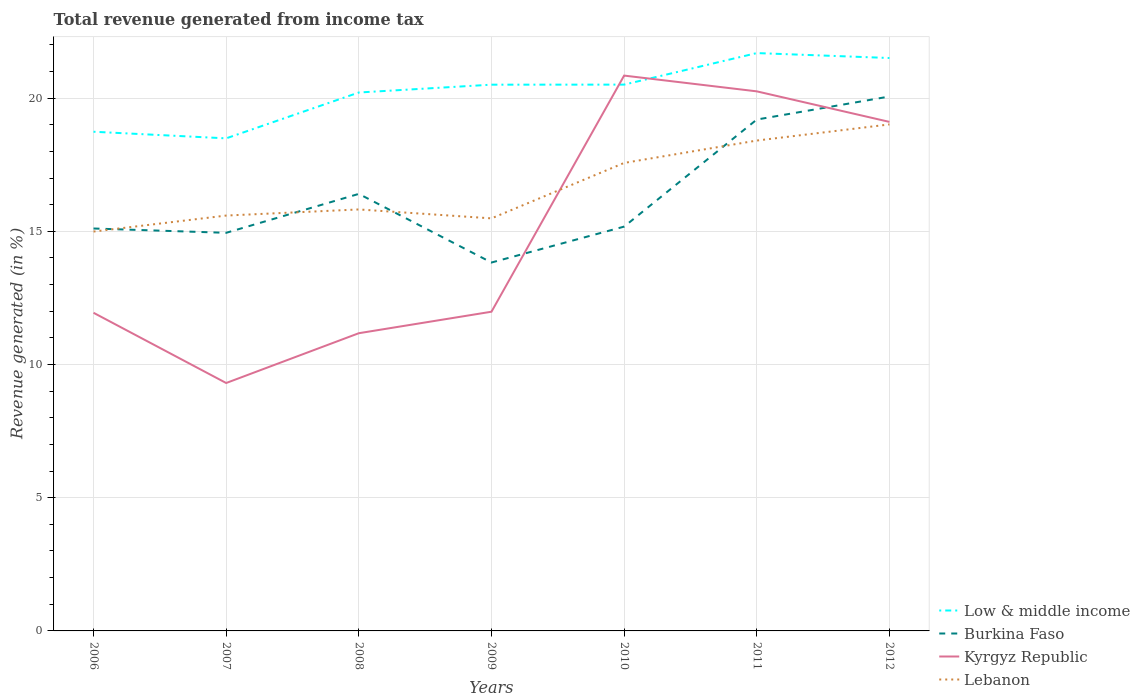Is the number of lines equal to the number of legend labels?
Your answer should be very brief. Yes. Across all years, what is the maximum total revenue generated in Low & middle income?
Your answer should be compact. 18.49. What is the total total revenue generated in Burkina Faso in the graph?
Ensure brevity in your answer.  1.28. What is the difference between the highest and the second highest total revenue generated in Low & middle income?
Make the answer very short. 3.2. What is the difference between the highest and the lowest total revenue generated in Lebanon?
Give a very brief answer. 3. Is the total revenue generated in Kyrgyz Republic strictly greater than the total revenue generated in Lebanon over the years?
Your answer should be compact. No. How many lines are there?
Give a very brief answer. 4. How many years are there in the graph?
Provide a short and direct response. 7. Does the graph contain grids?
Give a very brief answer. Yes. How many legend labels are there?
Give a very brief answer. 4. What is the title of the graph?
Offer a very short reply. Total revenue generated from income tax. What is the label or title of the Y-axis?
Give a very brief answer. Revenue generated (in %). What is the Revenue generated (in %) of Low & middle income in 2006?
Provide a short and direct response. 18.74. What is the Revenue generated (in %) in Burkina Faso in 2006?
Ensure brevity in your answer.  15.11. What is the Revenue generated (in %) in Kyrgyz Republic in 2006?
Provide a succinct answer. 11.94. What is the Revenue generated (in %) in Lebanon in 2006?
Ensure brevity in your answer.  14.99. What is the Revenue generated (in %) of Low & middle income in 2007?
Your response must be concise. 18.49. What is the Revenue generated (in %) in Burkina Faso in 2007?
Keep it short and to the point. 14.94. What is the Revenue generated (in %) in Kyrgyz Republic in 2007?
Your response must be concise. 9.31. What is the Revenue generated (in %) of Lebanon in 2007?
Offer a terse response. 15.59. What is the Revenue generated (in %) in Low & middle income in 2008?
Provide a short and direct response. 20.21. What is the Revenue generated (in %) of Burkina Faso in 2008?
Make the answer very short. 16.4. What is the Revenue generated (in %) of Kyrgyz Republic in 2008?
Offer a terse response. 11.17. What is the Revenue generated (in %) of Lebanon in 2008?
Offer a terse response. 15.82. What is the Revenue generated (in %) of Low & middle income in 2009?
Offer a very short reply. 20.5. What is the Revenue generated (in %) of Burkina Faso in 2009?
Your response must be concise. 13.83. What is the Revenue generated (in %) of Kyrgyz Republic in 2009?
Provide a short and direct response. 11.98. What is the Revenue generated (in %) of Lebanon in 2009?
Provide a short and direct response. 15.49. What is the Revenue generated (in %) of Low & middle income in 2010?
Make the answer very short. 20.51. What is the Revenue generated (in %) in Burkina Faso in 2010?
Ensure brevity in your answer.  15.18. What is the Revenue generated (in %) of Kyrgyz Republic in 2010?
Keep it short and to the point. 20.84. What is the Revenue generated (in %) of Lebanon in 2010?
Offer a terse response. 17.57. What is the Revenue generated (in %) in Low & middle income in 2011?
Ensure brevity in your answer.  21.69. What is the Revenue generated (in %) of Burkina Faso in 2011?
Your answer should be compact. 19.19. What is the Revenue generated (in %) in Kyrgyz Republic in 2011?
Ensure brevity in your answer.  20.25. What is the Revenue generated (in %) of Lebanon in 2011?
Ensure brevity in your answer.  18.41. What is the Revenue generated (in %) of Low & middle income in 2012?
Make the answer very short. 21.5. What is the Revenue generated (in %) in Burkina Faso in 2012?
Give a very brief answer. 20.06. What is the Revenue generated (in %) in Kyrgyz Republic in 2012?
Make the answer very short. 19.11. What is the Revenue generated (in %) of Lebanon in 2012?
Offer a terse response. 19.01. Across all years, what is the maximum Revenue generated (in %) of Low & middle income?
Offer a very short reply. 21.69. Across all years, what is the maximum Revenue generated (in %) of Burkina Faso?
Make the answer very short. 20.06. Across all years, what is the maximum Revenue generated (in %) in Kyrgyz Republic?
Offer a very short reply. 20.84. Across all years, what is the maximum Revenue generated (in %) in Lebanon?
Your answer should be very brief. 19.01. Across all years, what is the minimum Revenue generated (in %) in Low & middle income?
Your answer should be compact. 18.49. Across all years, what is the minimum Revenue generated (in %) in Burkina Faso?
Make the answer very short. 13.83. Across all years, what is the minimum Revenue generated (in %) in Kyrgyz Republic?
Your response must be concise. 9.31. Across all years, what is the minimum Revenue generated (in %) of Lebanon?
Make the answer very short. 14.99. What is the total Revenue generated (in %) in Low & middle income in the graph?
Your answer should be very brief. 141.64. What is the total Revenue generated (in %) in Burkina Faso in the graph?
Give a very brief answer. 114.71. What is the total Revenue generated (in %) of Kyrgyz Republic in the graph?
Ensure brevity in your answer.  104.61. What is the total Revenue generated (in %) of Lebanon in the graph?
Give a very brief answer. 116.87. What is the difference between the Revenue generated (in %) of Low & middle income in 2006 and that in 2007?
Your answer should be compact. 0.25. What is the difference between the Revenue generated (in %) of Burkina Faso in 2006 and that in 2007?
Make the answer very short. 0.16. What is the difference between the Revenue generated (in %) in Kyrgyz Republic in 2006 and that in 2007?
Your answer should be very brief. 2.64. What is the difference between the Revenue generated (in %) in Lebanon in 2006 and that in 2007?
Your response must be concise. -0.6. What is the difference between the Revenue generated (in %) in Low & middle income in 2006 and that in 2008?
Provide a short and direct response. -1.47. What is the difference between the Revenue generated (in %) of Burkina Faso in 2006 and that in 2008?
Give a very brief answer. -1.3. What is the difference between the Revenue generated (in %) in Kyrgyz Republic in 2006 and that in 2008?
Provide a succinct answer. 0.77. What is the difference between the Revenue generated (in %) of Lebanon in 2006 and that in 2008?
Give a very brief answer. -0.83. What is the difference between the Revenue generated (in %) in Low & middle income in 2006 and that in 2009?
Your answer should be very brief. -1.77. What is the difference between the Revenue generated (in %) of Burkina Faso in 2006 and that in 2009?
Give a very brief answer. 1.28. What is the difference between the Revenue generated (in %) of Kyrgyz Republic in 2006 and that in 2009?
Offer a very short reply. -0.04. What is the difference between the Revenue generated (in %) in Lebanon in 2006 and that in 2009?
Your answer should be compact. -0.49. What is the difference between the Revenue generated (in %) of Low & middle income in 2006 and that in 2010?
Make the answer very short. -1.77. What is the difference between the Revenue generated (in %) of Burkina Faso in 2006 and that in 2010?
Give a very brief answer. -0.07. What is the difference between the Revenue generated (in %) in Kyrgyz Republic in 2006 and that in 2010?
Keep it short and to the point. -8.9. What is the difference between the Revenue generated (in %) of Lebanon in 2006 and that in 2010?
Keep it short and to the point. -2.58. What is the difference between the Revenue generated (in %) of Low & middle income in 2006 and that in 2011?
Provide a short and direct response. -2.95. What is the difference between the Revenue generated (in %) of Burkina Faso in 2006 and that in 2011?
Your response must be concise. -4.09. What is the difference between the Revenue generated (in %) of Kyrgyz Republic in 2006 and that in 2011?
Provide a short and direct response. -8.31. What is the difference between the Revenue generated (in %) of Lebanon in 2006 and that in 2011?
Your answer should be compact. -3.42. What is the difference between the Revenue generated (in %) of Low & middle income in 2006 and that in 2012?
Your answer should be very brief. -2.77. What is the difference between the Revenue generated (in %) in Burkina Faso in 2006 and that in 2012?
Offer a very short reply. -4.95. What is the difference between the Revenue generated (in %) in Kyrgyz Republic in 2006 and that in 2012?
Your response must be concise. -7.17. What is the difference between the Revenue generated (in %) in Lebanon in 2006 and that in 2012?
Give a very brief answer. -4.02. What is the difference between the Revenue generated (in %) in Low & middle income in 2007 and that in 2008?
Keep it short and to the point. -1.72. What is the difference between the Revenue generated (in %) of Burkina Faso in 2007 and that in 2008?
Keep it short and to the point. -1.46. What is the difference between the Revenue generated (in %) in Kyrgyz Republic in 2007 and that in 2008?
Ensure brevity in your answer.  -1.87. What is the difference between the Revenue generated (in %) in Lebanon in 2007 and that in 2008?
Your answer should be very brief. -0.23. What is the difference between the Revenue generated (in %) of Low & middle income in 2007 and that in 2009?
Ensure brevity in your answer.  -2.02. What is the difference between the Revenue generated (in %) of Burkina Faso in 2007 and that in 2009?
Your answer should be very brief. 1.11. What is the difference between the Revenue generated (in %) in Kyrgyz Republic in 2007 and that in 2009?
Provide a short and direct response. -2.68. What is the difference between the Revenue generated (in %) in Lebanon in 2007 and that in 2009?
Your answer should be compact. 0.11. What is the difference between the Revenue generated (in %) of Low & middle income in 2007 and that in 2010?
Ensure brevity in your answer.  -2.02. What is the difference between the Revenue generated (in %) of Burkina Faso in 2007 and that in 2010?
Your response must be concise. -0.23. What is the difference between the Revenue generated (in %) in Kyrgyz Republic in 2007 and that in 2010?
Ensure brevity in your answer.  -11.54. What is the difference between the Revenue generated (in %) in Lebanon in 2007 and that in 2010?
Offer a terse response. -1.98. What is the difference between the Revenue generated (in %) in Low & middle income in 2007 and that in 2011?
Offer a very short reply. -3.2. What is the difference between the Revenue generated (in %) of Burkina Faso in 2007 and that in 2011?
Ensure brevity in your answer.  -4.25. What is the difference between the Revenue generated (in %) of Kyrgyz Republic in 2007 and that in 2011?
Keep it short and to the point. -10.95. What is the difference between the Revenue generated (in %) of Lebanon in 2007 and that in 2011?
Keep it short and to the point. -2.82. What is the difference between the Revenue generated (in %) of Low & middle income in 2007 and that in 2012?
Make the answer very short. -3.02. What is the difference between the Revenue generated (in %) of Burkina Faso in 2007 and that in 2012?
Offer a terse response. -5.12. What is the difference between the Revenue generated (in %) in Kyrgyz Republic in 2007 and that in 2012?
Ensure brevity in your answer.  -9.8. What is the difference between the Revenue generated (in %) in Lebanon in 2007 and that in 2012?
Provide a short and direct response. -3.42. What is the difference between the Revenue generated (in %) of Low & middle income in 2008 and that in 2009?
Your answer should be very brief. -0.29. What is the difference between the Revenue generated (in %) of Burkina Faso in 2008 and that in 2009?
Provide a short and direct response. 2.58. What is the difference between the Revenue generated (in %) in Kyrgyz Republic in 2008 and that in 2009?
Provide a short and direct response. -0.81. What is the difference between the Revenue generated (in %) in Lebanon in 2008 and that in 2009?
Offer a very short reply. 0.34. What is the difference between the Revenue generated (in %) of Low & middle income in 2008 and that in 2010?
Ensure brevity in your answer.  -0.3. What is the difference between the Revenue generated (in %) in Burkina Faso in 2008 and that in 2010?
Provide a short and direct response. 1.23. What is the difference between the Revenue generated (in %) in Kyrgyz Republic in 2008 and that in 2010?
Your response must be concise. -9.67. What is the difference between the Revenue generated (in %) in Lebanon in 2008 and that in 2010?
Provide a short and direct response. -1.75. What is the difference between the Revenue generated (in %) of Low & middle income in 2008 and that in 2011?
Provide a succinct answer. -1.48. What is the difference between the Revenue generated (in %) of Burkina Faso in 2008 and that in 2011?
Your answer should be compact. -2.79. What is the difference between the Revenue generated (in %) in Kyrgyz Republic in 2008 and that in 2011?
Give a very brief answer. -9.08. What is the difference between the Revenue generated (in %) of Lebanon in 2008 and that in 2011?
Give a very brief answer. -2.59. What is the difference between the Revenue generated (in %) of Low & middle income in 2008 and that in 2012?
Make the answer very short. -1.29. What is the difference between the Revenue generated (in %) in Burkina Faso in 2008 and that in 2012?
Offer a terse response. -3.66. What is the difference between the Revenue generated (in %) in Kyrgyz Republic in 2008 and that in 2012?
Provide a succinct answer. -7.93. What is the difference between the Revenue generated (in %) of Lebanon in 2008 and that in 2012?
Keep it short and to the point. -3.19. What is the difference between the Revenue generated (in %) in Low & middle income in 2009 and that in 2010?
Offer a very short reply. -0. What is the difference between the Revenue generated (in %) of Burkina Faso in 2009 and that in 2010?
Keep it short and to the point. -1.35. What is the difference between the Revenue generated (in %) in Kyrgyz Republic in 2009 and that in 2010?
Provide a succinct answer. -8.86. What is the difference between the Revenue generated (in %) in Lebanon in 2009 and that in 2010?
Keep it short and to the point. -2.08. What is the difference between the Revenue generated (in %) in Low & middle income in 2009 and that in 2011?
Offer a terse response. -1.19. What is the difference between the Revenue generated (in %) in Burkina Faso in 2009 and that in 2011?
Offer a terse response. -5.37. What is the difference between the Revenue generated (in %) in Kyrgyz Republic in 2009 and that in 2011?
Offer a terse response. -8.27. What is the difference between the Revenue generated (in %) in Lebanon in 2009 and that in 2011?
Offer a terse response. -2.92. What is the difference between the Revenue generated (in %) of Low & middle income in 2009 and that in 2012?
Keep it short and to the point. -1. What is the difference between the Revenue generated (in %) in Burkina Faso in 2009 and that in 2012?
Make the answer very short. -6.23. What is the difference between the Revenue generated (in %) in Kyrgyz Republic in 2009 and that in 2012?
Make the answer very short. -7.13. What is the difference between the Revenue generated (in %) of Lebanon in 2009 and that in 2012?
Offer a terse response. -3.53. What is the difference between the Revenue generated (in %) of Low & middle income in 2010 and that in 2011?
Provide a succinct answer. -1.18. What is the difference between the Revenue generated (in %) of Burkina Faso in 2010 and that in 2011?
Keep it short and to the point. -4.02. What is the difference between the Revenue generated (in %) in Kyrgyz Republic in 2010 and that in 2011?
Your answer should be compact. 0.59. What is the difference between the Revenue generated (in %) of Lebanon in 2010 and that in 2011?
Your answer should be compact. -0.84. What is the difference between the Revenue generated (in %) of Low & middle income in 2010 and that in 2012?
Provide a succinct answer. -1. What is the difference between the Revenue generated (in %) in Burkina Faso in 2010 and that in 2012?
Offer a terse response. -4.88. What is the difference between the Revenue generated (in %) in Kyrgyz Republic in 2010 and that in 2012?
Ensure brevity in your answer.  1.74. What is the difference between the Revenue generated (in %) of Lebanon in 2010 and that in 2012?
Make the answer very short. -1.45. What is the difference between the Revenue generated (in %) of Low & middle income in 2011 and that in 2012?
Your answer should be very brief. 0.19. What is the difference between the Revenue generated (in %) in Burkina Faso in 2011 and that in 2012?
Provide a short and direct response. -0.87. What is the difference between the Revenue generated (in %) of Kyrgyz Republic in 2011 and that in 2012?
Your response must be concise. 1.15. What is the difference between the Revenue generated (in %) of Lebanon in 2011 and that in 2012?
Your answer should be very brief. -0.61. What is the difference between the Revenue generated (in %) in Low & middle income in 2006 and the Revenue generated (in %) in Burkina Faso in 2007?
Keep it short and to the point. 3.79. What is the difference between the Revenue generated (in %) of Low & middle income in 2006 and the Revenue generated (in %) of Kyrgyz Republic in 2007?
Offer a very short reply. 9.43. What is the difference between the Revenue generated (in %) in Low & middle income in 2006 and the Revenue generated (in %) in Lebanon in 2007?
Keep it short and to the point. 3.15. What is the difference between the Revenue generated (in %) in Burkina Faso in 2006 and the Revenue generated (in %) in Kyrgyz Republic in 2007?
Your answer should be very brief. 5.8. What is the difference between the Revenue generated (in %) in Burkina Faso in 2006 and the Revenue generated (in %) in Lebanon in 2007?
Your answer should be compact. -0.49. What is the difference between the Revenue generated (in %) of Kyrgyz Republic in 2006 and the Revenue generated (in %) of Lebanon in 2007?
Offer a terse response. -3.65. What is the difference between the Revenue generated (in %) in Low & middle income in 2006 and the Revenue generated (in %) in Burkina Faso in 2008?
Ensure brevity in your answer.  2.33. What is the difference between the Revenue generated (in %) of Low & middle income in 2006 and the Revenue generated (in %) of Kyrgyz Republic in 2008?
Ensure brevity in your answer.  7.56. What is the difference between the Revenue generated (in %) of Low & middle income in 2006 and the Revenue generated (in %) of Lebanon in 2008?
Ensure brevity in your answer.  2.92. What is the difference between the Revenue generated (in %) in Burkina Faso in 2006 and the Revenue generated (in %) in Kyrgyz Republic in 2008?
Make the answer very short. 3.93. What is the difference between the Revenue generated (in %) in Burkina Faso in 2006 and the Revenue generated (in %) in Lebanon in 2008?
Offer a terse response. -0.72. What is the difference between the Revenue generated (in %) in Kyrgyz Republic in 2006 and the Revenue generated (in %) in Lebanon in 2008?
Give a very brief answer. -3.88. What is the difference between the Revenue generated (in %) in Low & middle income in 2006 and the Revenue generated (in %) in Burkina Faso in 2009?
Give a very brief answer. 4.91. What is the difference between the Revenue generated (in %) in Low & middle income in 2006 and the Revenue generated (in %) in Kyrgyz Republic in 2009?
Keep it short and to the point. 6.76. What is the difference between the Revenue generated (in %) of Low & middle income in 2006 and the Revenue generated (in %) of Lebanon in 2009?
Ensure brevity in your answer.  3.25. What is the difference between the Revenue generated (in %) of Burkina Faso in 2006 and the Revenue generated (in %) of Kyrgyz Republic in 2009?
Give a very brief answer. 3.12. What is the difference between the Revenue generated (in %) in Burkina Faso in 2006 and the Revenue generated (in %) in Lebanon in 2009?
Provide a succinct answer. -0.38. What is the difference between the Revenue generated (in %) in Kyrgyz Republic in 2006 and the Revenue generated (in %) in Lebanon in 2009?
Provide a short and direct response. -3.54. What is the difference between the Revenue generated (in %) of Low & middle income in 2006 and the Revenue generated (in %) of Burkina Faso in 2010?
Your answer should be compact. 3.56. What is the difference between the Revenue generated (in %) of Low & middle income in 2006 and the Revenue generated (in %) of Kyrgyz Republic in 2010?
Give a very brief answer. -2.11. What is the difference between the Revenue generated (in %) of Low & middle income in 2006 and the Revenue generated (in %) of Lebanon in 2010?
Your response must be concise. 1.17. What is the difference between the Revenue generated (in %) in Burkina Faso in 2006 and the Revenue generated (in %) in Kyrgyz Republic in 2010?
Provide a succinct answer. -5.74. What is the difference between the Revenue generated (in %) in Burkina Faso in 2006 and the Revenue generated (in %) in Lebanon in 2010?
Your answer should be very brief. -2.46. What is the difference between the Revenue generated (in %) in Kyrgyz Republic in 2006 and the Revenue generated (in %) in Lebanon in 2010?
Your answer should be very brief. -5.62. What is the difference between the Revenue generated (in %) of Low & middle income in 2006 and the Revenue generated (in %) of Burkina Faso in 2011?
Offer a terse response. -0.46. What is the difference between the Revenue generated (in %) in Low & middle income in 2006 and the Revenue generated (in %) in Kyrgyz Republic in 2011?
Offer a terse response. -1.52. What is the difference between the Revenue generated (in %) of Low & middle income in 2006 and the Revenue generated (in %) of Lebanon in 2011?
Provide a short and direct response. 0.33. What is the difference between the Revenue generated (in %) in Burkina Faso in 2006 and the Revenue generated (in %) in Kyrgyz Republic in 2011?
Give a very brief answer. -5.15. What is the difference between the Revenue generated (in %) of Burkina Faso in 2006 and the Revenue generated (in %) of Lebanon in 2011?
Provide a succinct answer. -3.3. What is the difference between the Revenue generated (in %) of Kyrgyz Republic in 2006 and the Revenue generated (in %) of Lebanon in 2011?
Offer a very short reply. -6.46. What is the difference between the Revenue generated (in %) of Low & middle income in 2006 and the Revenue generated (in %) of Burkina Faso in 2012?
Your answer should be compact. -1.32. What is the difference between the Revenue generated (in %) in Low & middle income in 2006 and the Revenue generated (in %) in Kyrgyz Republic in 2012?
Give a very brief answer. -0.37. What is the difference between the Revenue generated (in %) of Low & middle income in 2006 and the Revenue generated (in %) of Lebanon in 2012?
Provide a short and direct response. -0.28. What is the difference between the Revenue generated (in %) in Burkina Faso in 2006 and the Revenue generated (in %) in Kyrgyz Republic in 2012?
Your answer should be compact. -4. What is the difference between the Revenue generated (in %) of Burkina Faso in 2006 and the Revenue generated (in %) of Lebanon in 2012?
Give a very brief answer. -3.91. What is the difference between the Revenue generated (in %) of Kyrgyz Republic in 2006 and the Revenue generated (in %) of Lebanon in 2012?
Offer a very short reply. -7.07. What is the difference between the Revenue generated (in %) in Low & middle income in 2007 and the Revenue generated (in %) in Burkina Faso in 2008?
Keep it short and to the point. 2.08. What is the difference between the Revenue generated (in %) of Low & middle income in 2007 and the Revenue generated (in %) of Kyrgyz Republic in 2008?
Your answer should be compact. 7.31. What is the difference between the Revenue generated (in %) in Low & middle income in 2007 and the Revenue generated (in %) in Lebanon in 2008?
Give a very brief answer. 2.67. What is the difference between the Revenue generated (in %) in Burkina Faso in 2007 and the Revenue generated (in %) in Kyrgyz Republic in 2008?
Offer a terse response. 3.77. What is the difference between the Revenue generated (in %) of Burkina Faso in 2007 and the Revenue generated (in %) of Lebanon in 2008?
Make the answer very short. -0.88. What is the difference between the Revenue generated (in %) of Kyrgyz Republic in 2007 and the Revenue generated (in %) of Lebanon in 2008?
Your response must be concise. -6.51. What is the difference between the Revenue generated (in %) of Low & middle income in 2007 and the Revenue generated (in %) of Burkina Faso in 2009?
Make the answer very short. 4.66. What is the difference between the Revenue generated (in %) of Low & middle income in 2007 and the Revenue generated (in %) of Kyrgyz Republic in 2009?
Offer a terse response. 6.51. What is the difference between the Revenue generated (in %) in Low & middle income in 2007 and the Revenue generated (in %) in Lebanon in 2009?
Offer a terse response. 3. What is the difference between the Revenue generated (in %) of Burkina Faso in 2007 and the Revenue generated (in %) of Kyrgyz Republic in 2009?
Your answer should be compact. 2.96. What is the difference between the Revenue generated (in %) in Burkina Faso in 2007 and the Revenue generated (in %) in Lebanon in 2009?
Ensure brevity in your answer.  -0.54. What is the difference between the Revenue generated (in %) of Kyrgyz Republic in 2007 and the Revenue generated (in %) of Lebanon in 2009?
Make the answer very short. -6.18. What is the difference between the Revenue generated (in %) in Low & middle income in 2007 and the Revenue generated (in %) in Burkina Faso in 2010?
Make the answer very short. 3.31. What is the difference between the Revenue generated (in %) of Low & middle income in 2007 and the Revenue generated (in %) of Kyrgyz Republic in 2010?
Offer a very short reply. -2.36. What is the difference between the Revenue generated (in %) of Low & middle income in 2007 and the Revenue generated (in %) of Lebanon in 2010?
Offer a terse response. 0.92. What is the difference between the Revenue generated (in %) of Burkina Faso in 2007 and the Revenue generated (in %) of Kyrgyz Republic in 2010?
Your answer should be very brief. -5.9. What is the difference between the Revenue generated (in %) of Burkina Faso in 2007 and the Revenue generated (in %) of Lebanon in 2010?
Make the answer very short. -2.62. What is the difference between the Revenue generated (in %) of Kyrgyz Republic in 2007 and the Revenue generated (in %) of Lebanon in 2010?
Provide a short and direct response. -8.26. What is the difference between the Revenue generated (in %) of Low & middle income in 2007 and the Revenue generated (in %) of Burkina Faso in 2011?
Offer a terse response. -0.71. What is the difference between the Revenue generated (in %) of Low & middle income in 2007 and the Revenue generated (in %) of Kyrgyz Republic in 2011?
Provide a short and direct response. -1.76. What is the difference between the Revenue generated (in %) of Low & middle income in 2007 and the Revenue generated (in %) of Lebanon in 2011?
Make the answer very short. 0.08. What is the difference between the Revenue generated (in %) of Burkina Faso in 2007 and the Revenue generated (in %) of Kyrgyz Republic in 2011?
Offer a very short reply. -5.31. What is the difference between the Revenue generated (in %) of Burkina Faso in 2007 and the Revenue generated (in %) of Lebanon in 2011?
Provide a succinct answer. -3.46. What is the difference between the Revenue generated (in %) of Kyrgyz Republic in 2007 and the Revenue generated (in %) of Lebanon in 2011?
Your answer should be very brief. -9.1. What is the difference between the Revenue generated (in %) in Low & middle income in 2007 and the Revenue generated (in %) in Burkina Faso in 2012?
Your response must be concise. -1.57. What is the difference between the Revenue generated (in %) in Low & middle income in 2007 and the Revenue generated (in %) in Kyrgyz Republic in 2012?
Offer a terse response. -0.62. What is the difference between the Revenue generated (in %) in Low & middle income in 2007 and the Revenue generated (in %) in Lebanon in 2012?
Offer a very short reply. -0.52. What is the difference between the Revenue generated (in %) of Burkina Faso in 2007 and the Revenue generated (in %) of Kyrgyz Republic in 2012?
Keep it short and to the point. -4.16. What is the difference between the Revenue generated (in %) of Burkina Faso in 2007 and the Revenue generated (in %) of Lebanon in 2012?
Your answer should be compact. -4.07. What is the difference between the Revenue generated (in %) in Kyrgyz Republic in 2007 and the Revenue generated (in %) in Lebanon in 2012?
Give a very brief answer. -9.71. What is the difference between the Revenue generated (in %) in Low & middle income in 2008 and the Revenue generated (in %) in Burkina Faso in 2009?
Provide a succinct answer. 6.38. What is the difference between the Revenue generated (in %) in Low & middle income in 2008 and the Revenue generated (in %) in Kyrgyz Republic in 2009?
Your answer should be very brief. 8.23. What is the difference between the Revenue generated (in %) in Low & middle income in 2008 and the Revenue generated (in %) in Lebanon in 2009?
Make the answer very short. 4.72. What is the difference between the Revenue generated (in %) in Burkina Faso in 2008 and the Revenue generated (in %) in Kyrgyz Republic in 2009?
Ensure brevity in your answer.  4.42. What is the difference between the Revenue generated (in %) of Burkina Faso in 2008 and the Revenue generated (in %) of Lebanon in 2009?
Ensure brevity in your answer.  0.92. What is the difference between the Revenue generated (in %) in Kyrgyz Republic in 2008 and the Revenue generated (in %) in Lebanon in 2009?
Give a very brief answer. -4.31. What is the difference between the Revenue generated (in %) of Low & middle income in 2008 and the Revenue generated (in %) of Burkina Faso in 2010?
Offer a terse response. 5.03. What is the difference between the Revenue generated (in %) of Low & middle income in 2008 and the Revenue generated (in %) of Kyrgyz Republic in 2010?
Offer a very short reply. -0.64. What is the difference between the Revenue generated (in %) of Low & middle income in 2008 and the Revenue generated (in %) of Lebanon in 2010?
Keep it short and to the point. 2.64. What is the difference between the Revenue generated (in %) in Burkina Faso in 2008 and the Revenue generated (in %) in Kyrgyz Republic in 2010?
Your answer should be very brief. -4.44. What is the difference between the Revenue generated (in %) of Burkina Faso in 2008 and the Revenue generated (in %) of Lebanon in 2010?
Provide a succinct answer. -1.16. What is the difference between the Revenue generated (in %) in Kyrgyz Republic in 2008 and the Revenue generated (in %) in Lebanon in 2010?
Ensure brevity in your answer.  -6.39. What is the difference between the Revenue generated (in %) in Low & middle income in 2008 and the Revenue generated (in %) in Burkina Faso in 2011?
Give a very brief answer. 1.01. What is the difference between the Revenue generated (in %) in Low & middle income in 2008 and the Revenue generated (in %) in Kyrgyz Republic in 2011?
Keep it short and to the point. -0.04. What is the difference between the Revenue generated (in %) of Low & middle income in 2008 and the Revenue generated (in %) of Lebanon in 2011?
Make the answer very short. 1.8. What is the difference between the Revenue generated (in %) in Burkina Faso in 2008 and the Revenue generated (in %) in Kyrgyz Republic in 2011?
Your answer should be very brief. -3.85. What is the difference between the Revenue generated (in %) of Burkina Faso in 2008 and the Revenue generated (in %) of Lebanon in 2011?
Provide a short and direct response. -2. What is the difference between the Revenue generated (in %) of Kyrgyz Republic in 2008 and the Revenue generated (in %) of Lebanon in 2011?
Ensure brevity in your answer.  -7.23. What is the difference between the Revenue generated (in %) of Low & middle income in 2008 and the Revenue generated (in %) of Burkina Faso in 2012?
Offer a very short reply. 0.15. What is the difference between the Revenue generated (in %) of Low & middle income in 2008 and the Revenue generated (in %) of Kyrgyz Republic in 2012?
Your response must be concise. 1.1. What is the difference between the Revenue generated (in %) of Low & middle income in 2008 and the Revenue generated (in %) of Lebanon in 2012?
Your response must be concise. 1.2. What is the difference between the Revenue generated (in %) of Burkina Faso in 2008 and the Revenue generated (in %) of Kyrgyz Republic in 2012?
Provide a short and direct response. -2.7. What is the difference between the Revenue generated (in %) of Burkina Faso in 2008 and the Revenue generated (in %) of Lebanon in 2012?
Provide a short and direct response. -2.61. What is the difference between the Revenue generated (in %) of Kyrgyz Republic in 2008 and the Revenue generated (in %) of Lebanon in 2012?
Your answer should be very brief. -7.84. What is the difference between the Revenue generated (in %) of Low & middle income in 2009 and the Revenue generated (in %) of Burkina Faso in 2010?
Provide a short and direct response. 5.33. What is the difference between the Revenue generated (in %) of Low & middle income in 2009 and the Revenue generated (in %) of Kyrgyz Republic in 2010?
Ensure brevity in your answer.  -0.34. What is the difference between the Revenue generated (in %) in Low & middle income in 2009 and the Revenue generated (in %) in Lebanon in 2010?
Provide a succinct answer. 2.94. What is the difference between the Revenue generated (in %) in Burkina Faso in 2009 and the Revenue generated (in %) in Kyrgyz Republic in 2010?
Provide a succinct answer. -7.02. What is the difference between the Revenue generated (in %) of Burkina Faso in 2009 and the Revenue generated (in %) of Lebanon in 2010?
Give a very brief answer. -3.74. What is the difference between the Revenue generated (in %) of Kyrgyz Republic in 2009 and the Revenue generated (in %) of Lebanon in 2010?
Your answer should be very brief. -5.59. What is the difference between the Revenue generated (in %) in Low & middle income in 2009 and the Revenue generated (in %) in Burkina Faso in 2011?
Give a very brief answer. 1.31. What is the difference between the Revenue generated (in %) in Low & middle income in 2009 and the Revenue generated (in %) in Kyrgyz Republic in 2011?
Provide a succinct answer. 0.25. What is the difference between the Revenue generated (in %) in Low & middle income in 2009 and the Revenue generated (in %) in Lebanon in 2011?
Your response must be concise. 2.1. What is the difference between the Revenue generated (in %) in Burkina Faso in 2009 and the Revenue generated (in %) in Kyrgyz Republic in 2011?
Make the answer very short. -6.42. What is the difference between the Revenue generated (in %) in Burkina Faso in 2009 and the Revenue generated (in %) in Lebanon in 2011?
Provide a short and direct response. -4.58. What is the difference between the Revenue generated (in %) of Kyrgyz Republic in 2009 and the Revenue generated (in %) of Lebanon in 2011?
Provide a short and direct response. -6.42. What is the difference between the Revenue generated (in %) of Low & middle income in 2009 and the Revenue generated (in %) of Burkina Faso in 2012?
Ensure brevity in your answer.  0.44. What is the difference between the Revenue generated (in %) of Low & middle income in 2009 and the Revenue generated (in %) of Kyrgyz Republic in 2012?
Your answer should be compact. 1.4. What is the difference between the Revenue generated (in %) in Low & middle income in 2009 and the Revenue generated (in %) in Lebanon in 2012?
Provide a short and direct response. 1.49. What is the difference between the Revenue generated (in %) in Burkina Faso in 2009 and the Revenue generated (in %) in Kyrgyz Republic in 2012?
Keep it short and to the point. -5.28. What is the difference between the Revenue generated (in %) in Burkina Faso in 2009 and the Revenue generated (in %) in Lebanon in 2012?
Ensure brevity in your answer.  -5.18. What is the difference between the Revenue generated (in %) in Kyrgyz Republic in 2009 and the Revenue generated (in %) in Lebanon in 2012?
Your answer should be compact. -7.03. What is the difference between the Revenue generated (in %) in Low & middle income in 2010 and the Revenue generated (in %) in Burkina Faso in 2011?
Your answer should be very brief. 1.31. What is the difference between the Revenue generated (in %) in Low & middle income in 2010 and the Revenue generated (in %) in Kyrgyz Republic in 2011?
Your answer should be compact. 0.25. What is the difference between the Revenue generated (in %) of Low & middle income in 2010 and the Revenue generated (in %) of Lebanon in 2011?
Your answer should be very brief. 2.1. What is the difference between the Revenue generated (in %) in Burkina Faso in 2010 and the Revenue generated (in %) in Kyrgyz Republic in 2011?
Ensure brevity in your answer.  -5.08. What is the difference between the Revenue generated (in %) in Burkina Faso in 2010 and the Revenue generated (in %) in Lebanon in 2011?
Provide a succinct answer. -3.23. What is the difference between the Revenue generated (in %) of Kyrgyz Republic in 2010 and the Revenue generated (in %) of Lebanon in 2011?
Make the answer very short. 2.44. What is the difference between the Revenue generated (in %) of Low & middle income in 2010 and the Revenue generated (in %) of Burkina Faso in 2012?
Offer a very short reply. 0.45. What is the difference between the Revenue generated (in %) of Low & middle income in 2010 and the Revenue generated (in %) of Kyrgyz Republic in 2012?
Offer a terse response. 1.4. What is the difference between the Revenue generated (in %) of Low & middle income in 2010 and the Revenue generated (in %) of Lebanon in 2012?
Your response must be concise. 1.49. What is the difference between the Revenue generated (in %) of Burkina Faso in 2010 and the Revenue generated (in %) of Kyrgyz Republic in 2012?
Your response must be concise. -3.93. What is the difference between the Revenue generated (in %) in Burkina Faso in 2010 and the Revenue generated (in %) in Lebanon in 2012?
Offer a terse response. -3.84. What is the difference between the Revenue generated (in %) in Kyrgyz Republic in 2010 and the Revenue generated (in %) in Lebanon in 2012?
Offer a very short reply. 1.83. What is the difference between the Revenue generated (in %) of Low & middle income in 2011 and the Revenue generated (in %) of Burkina Faso in 2012?
Keep it short and to the point. 1.63. What is the difference between the Revenue generated (in %) of Low & middle income in 2011 and the Revenue generated (in %) of Kyrgyz Republic in 2012?
Your response must be concise. 2.58. What is the difference between the Revenue generated (in %) in Low & middle income in 2011 and the Revenue generated (in %) in Lebanon in 2012?
Provide a short and direct response. 2.68. What is the difference between the Revenue generated (in %) in Burkina Faso in 2011 and the Revenue generated (in %) in Kyrgyz Republic in 2012?
Your answer should be very brief. 0.09. What is the difference between the Revenue generated (in %) in Burkina Faso in 2011 and the Revenue generated (in %) in Lebanon in 2012?
Your answer should be compact. 0.18. What is the difference between the Revenue generated (in %) of Kyrgyz Republic in 2011 and the Revenue generated (in %) of Lebanon in 2012?
Ensure brevity in your answer.  1.24. What is the average Revenue generated (in %) in Low & middle income per year?
Ensure brevity in your answer.  20.23. What is the average Revenue generated (in %) of Burkina Faso per year?
Provide a short and direct response. 16.39. What is the average Revenue generated (in %) in Kyrgyz Republic per year?
Offer a terse response. 14.94. What is the average Revenue generated (in %) of Lebanon per year?
Provide a succinct answer. 16.7. In the year 2006, what is the difference between the Revenue generated (in %) in Low & middle income and Revenue generated (in %) in Burkina Faso?
Provide a short and direct response. 3.63. In the year 2006, what is the difference between the Revenue generated (in %) of Low & middle income and Revenue generated (in %) of Kyrgyz Republic?
Give a very brief answer. 6.8. In the year 2006, what is the difference between the Revenue generated (in %) in Low & middle income and Revenue generated (in %) in Lebanon?
Offer a terse response. 3.75. In the year 2006, what is the difference between the Revenue generated (in %) in Burkina Faso and Revenue generated (in %) in Kyrgyz Republic?
Offer a terse response. 3.16. In the year 2006, what is the difference between the Revenue generated (in %) in Burkina Faso and Revenue generated (in %) in Lebanon?
Your response must be concise. 0.11. In the year 2006, what is the difference between the Revenue generated (in %) of Kyrgyz Republic and Revenue generated (in %) of Lebanon?
Keep it short and to the point. -3.05. In the year 2007, what is the difference between the Revenue generated (in %) of Low & middle income and Revenue generated (in %) of Burkina Faso?
Your answer should be very brief. 3.55. In the year 2007, what is the difference between the Revenue generated (in %) of Low & middle income and Revenue generated (in %) of Kyrgyz Republic?
Provide a short and direct response. 9.18. In the year 2007, what is the difference between the Revenue generated (in %) in Low & middle income and Revenue generated (in %) in Lebanon?
Offer a very short reply. 2.9. In the year 2007, what is the difference between the Revenue generated (in %) of Burkina Faso and Revenue generated (in %) of Kyrgyz Republic?
Your answer should be compact. 5.64. In the year 2007, what is the difference between the Revenue generated (in %) of Burkina Faso and Revenue generated (in %) of Lebanon?
Your response must be concise. -0.65. In the year 2007, what is the difference between the Revenue generated (in %) of Kyrgyz Republic and Revenue generated (in %) of Lebanon?
Your answer should be very brief. -6.29. In the year 2008, what is the difference between the Revenue generated (in %) of Low & middle income and Revenue generated (in %) of Burkina Faso?
Provide a short and direct response. 3.81. In the year 2008, what is the difference between the Revenue generated (in %) of Low & middle income and Revenue generated (in %) of Kyrgyz Republic?
Make the answer very short. 9.04. In the year 2008, what is the difference between the Revenue generated (in %) of Low & middle income and Revenue generated (in %) of Lebanon?
Keep it short and to the point. 4.39. In the year 2008, what is the difference between the Revenue generated (in %) in Burkina Faso and Revenue generated (in %) in Kyrgyz Republic?
Offer a terse response. 5.23. In the year 2008, what is the difference between the Revenue generated (in %) of Burkina Faso and Revenue generated (in %) of Lebanon?
Ensure brevity in your answer.  0.58. In the year 2008, what is the difference between the Revenue generated (in %) of Kyrgyz Republic and Revenue generated (in %) of Lebanon?
Your answer should be compact. -4.65. In the year 2009, what is the difference between the Revenue generated (in %) in Low & middle income and Revenue generated (in %) in Burkina Faso?
Your answer should be compact. 6.68. In the year 2009, what is the difference between the Revenue generated (in %) of Low & middle income and Revenue generated (in %) of Kyrgyz Republic?
Offer a very short reply. 8.52. In the year 2009, what is the difference between the Revenue generated (in %) in Low & middle income and Revenue generated (in %) in Lebanon?
Make the answer very short. 5.02. In the year 2009, what is the difference between the Revenue generated (in %) of Burkina Faso and Revenue generated (in %) of Kyrgyz Republic?
Ensure brevity in your answer.  1.85. In the year 2009, what is the difference between the Revenue generated (in %) of Burkina Faso and Revenue generated (in %) of Lebanon?
Your response must be concise. -1.66. In the year 2009, what is the difference between the Revenue generated (in %) in Kyrgyz Republic and Revenue generated (in %) in Lebanon?
Provide a succinct answer. -3.5. In the year 2010, what is the difference between the Revenue generated (in %) in Low & middle income and Revenue generated (in %) in Burkina Faso?
Offer a very short reply. 5.33. In the year 2010, what is the difference between the Revenue generated (in %) in Low & middle income and Revenue generated (in %) in Kyrgyz Republic?
Offer a very short reply. -0.34. In the year 2010, what is the difference between the Revenue generated (in %) in Low & middle income and Revenue generated (in %) in Lebanon?
Your response must be concise. 2.94. In the year 2010, what is the difference between the Revenue generated (in %) in Burkina Faso and Revenue generated (in %) in Kyrgyz Republic?
Ensure brevity in your answer.  -5.67. In the year 2010, what is the difference between the Revenue generated (in %) of Burkina Faso and Revenue generated (in %) of Lebanon?
Ensure brevity in your answer.  -2.39. In the year 2010, what is the difference between the Revenue generated (in %) of Kyrgyz Republic and Revenue generated (in %) of Lebanon?
Your answer should be very brief. 3.28. In the year 2011, what is the difference between the Revenue generated (in %) of Low & middle income and Revenue generated (in %) of Burkina Faso?
Provide a succinct answer. 2.5. In the year 2011, what is the difference between the Revenue generated (in %) of Low & middle income and Revenue generated (in %) of Kyrgyz Republic?
Ensure brevity in your answer.  1.44. In the year 2011, what is the difference between the Revenue generated (in %) in Low & middle income and Revenue generated (in %) in Lebanon?
Your answer should be very brief. 3.28. In the year 2011, what is the difference between the Revenue generated (in %) of Burkina Faso and Revenue generated (in %) of Kyrgyz Republic?
Keep it short and to the point. -1.06. In the year 2011, what is the difference between the Revenue generated (in %) of Burkina Faso and Revenue generated (in %) of Lebanon?
Keep it short and to the point. 0.79. In the year 2011, what is the difference between the Revenue generated (in %) in Kyrgyz Republic and Revenue generated (in %) in Lebanon?
Provide a short and direct response. 1.85. In the year 2012, what is the difference between the Revenue generated (in %) in Low & middle income and Revenue generated (in %) in Burkina Faso?
Provide a short and direct response. 1.44. In the year 2012, what is the difference between the Revenue generated (in %) in Low & middle income and Revenue generated (in %) in Kyrgyz Republic?
Offer a very short reply. 2.4. In the year 2012, what is the difference between the Revenue generated (in %) in Low & middle income and Revenue generated (in %) in Lebanon?
Your response must be concise. 2.49. In the year 2012, what is the difference between the Revenue generated (in %) of Burkina Faso and Revenue generated (in %) of Kyrgyz Republic?
Give a very brief answer. 0.95. In the year 2012, what is the difference between the Revenue generated (in %) of Burkina Faso and Revenue generated (in %) of Lebanon?
Offer a very short reply. 1.05. In the year 2012, what is the difference between the Revenue generated (in %) of Kyrgyz Republic and Revenue generated (in %) of Lebanon?
Your answer should be very brief. 0.09. What is the ratio of the Revenue generated (in %) of Low & middle income in 2006 to that in 2007?
Your response must be concise. 1.01. What is the ratio of the Revenue generated (in %) of Burkina Faso in 2006 to that in 2007?
Offer a very short reply. 1.01. What is the ratio of the Revenue generated (in %) in Kyrgyz Republic in 2006 to that in 2007?
Offer a very short reply. 1.28. What is the ratio of the Revenue generated (in %) of Lebanon in 2006 to that in 2007?
Keep it short and to the point. 0.96. What is the ratio of the Revenue generated (in %) in Low & middle income in 2006 to that in 2008?
Offer a terse response. 0.93. What is the ratio of the Revenue generated (in %) of Burkina Faso in 2006 to that in 2008?
Provide a short and direct response. 0.92. What is the ratio of the Revenue generated (in %) of Kyrgyz Republic in 2006 to that in 2008?
Provide a succinct answer. 1.07. What is the ratio of the Revenue generated (in %) in Lebanon in 2006 to that in 2008?
Provide a succinct answer. 0.95. What is the ratio of the Revenue generated (in %) in Low & middle income in 2006 to that in 2009?
Keep it short and to the point. 0.91. What is the ratio of the Revenue generated (in %) in Burkina Faso in 2006 to that in 2009?
Give a very brief answer. 1.09. What is the ratio of the Revenue generated (in %) in Kyrgyz Republic in 2006 to that in 2009?
Your answer should be very brief. 1. What is the ratio of the Revenue generated (in %) of Lebanon in 2006 to that in 2009?
Provide a succinct answer. 0.97. What is the ratio of the Revenue generated (in %) in Low & middle income in 2006 to that in 2010?
Your answer should be compact. 0.91. What is the ratio of the Revenue generated (in %) of Kyrgyz Republic in 2006 to that in 2010?
Make the answer very short. 0.57. What is the ratio of the Revenue generated (in %) of Lebanon in 2006 to that in 2010?
Provide a succinct answer. 0.85. What is the ratio of the Revenue generated (in %) of Low & middle income in 2006 to that in 2011?
Your answer should be compact. 0.86. What is the ratio of the Revenue generated (in %) of Burkina Faso in 2006 to that in 2011?
Your answer should be compact. 0.79. What is the ratio of the Revenue generated (in %) in Kyrgyz Republic in 2006 to that in 2011?
Your response must be concise. 0.59. What is the ratio of the Revenue generated (in %) in Lebanon in 2006 to that in 2011?
Offer a very short reply. 0.81. What is the ratio of the Revenue generated (in %) of Low & middle income in 2006 to that in 2012?
Offer a very short reply. 0.87. What is the ratio of the Revenue generated (in %) in Burkina Faso in 2006 to that in 2012?
Provide a succinct answer. 0.75. What is the ratio of the Revenue generated (in %) in Lebanon in 2006 to that in 2012?
Ensure brevity in your answer.  0.79. What is the ratio of the Revenue generated (in %) of Low & middle income in 2007 to that in 2008?
Offer a terse response. 0.91. What is the ratio of the Revenue generated (in %) in Burkina Faso in 2007 to that in 2008?
Offer a terse response. 0.91. What is the ratio of the Revenue generated (in %) of Kyrgyz Republic in 2007 to that in 2008?
Give a very brief answer. 0.83. What is the ratio of the Revenue generated (in %) in Lebanon in 2007 to that in 2008?
Make the answer very short. 0.99. What is the ratio of the Revenue generated (in %) of Low & middle income in 2007 to that in 2009?
Your answer should be compact. 0.9. What is the ratio of the Revenue generated (in %) in Burkina Faso in 2007 to that in 2009?
Provide a short and direct response. 1.08. What is the ratio of the Revenue generated (in %) in Kyrgyz Republic in 2007 to that in 2009?
Ensure brevity in your answer.  0.78. What is the ratio of the Revenue generated (in %) in Lebanon in 2007 to that in 2009?
Your response must be concise. 1.01. What is the ratio of the Revenue generated (in %) of Low & middle income in 2007 to that in 2010?
Give a very brief answer. 0.9. What is the ratio of the Revenue generated (in %) of Burkina Faso in 2007 to that in 2010?
Your answer should be very brief. 0.98. What is the ratio of the Revenue generated (in %) of Kyrgyz Republic in 2007 to that in 2010?
Your answer should be compact. 0.45. What is the ratio of the Revenue generated (in %) in Lebanon in 2007 to that in 2010?
Offer a terse response. 0.89. What is the ratio of the Revenue generated (in %) of Low & middle income in 2007 to that in 2011?
Your answer should be compact. 0.85. What is the ratio of the Revenue generated (in %) of Burkina Faso in 2007 to that in 2011?
Give a very brief answer. 0.78. What is the ratio of the Revenue generated (in %) of Kyrgyz Republic in 2007 to that in 2011?
Provide a succinct answer. 0.46. What is the ratio of the Revenue generated (in %) of Lebanon in 2007 to that in 2011?
Ensure brevity in your answer.  0.85. What is the ratio of the Revenue generated (in %) of Low & middle income in 2007 to that in 2012?
Your answer should be very brief. 0.86. What is the ratio of the Revenue generated (in %) of Burkina Faso in 2007 to that in 2012?
Your answer should be compact. 0.74. What is the ratio of the Revenue generated (in %) of Kyrgyz Republic in 2007 to that in 2012?
Make the answer very short. 0.49. What is the ratio of the Revenue generated (in %) of Lebanon in 2007 to that in 2012?
Provide a succinct answer. 0.82. What is the ratio of the Revenue generated (in %) in Low & middle income in 2008 to that in 2009?
Your answer should be very brief. 0.99. What is the ratio of the Revenue generated (in %) of Burkina Faso in 2008 to that in 2009?
Your answer should be compact. 1.19. What is the ratio of the Revenue generated (in %) of Kyrgyz Republic in 2008 to that in 2009?
Provide a succinct answer. 0.93. What is the ratio of the Revenue generated (in %) of Lebanon in 2008 to that in 2009?
Provide a short and direct response. 1.02. What is the ratio of the Revenue generated (in %) of Low & middle income in 2008 to that in 2010?
Your answer should be very brief. 0.99. What is the ratio of the Revenue generated (in %) of Burkina Faso in 2008 to that in 2010?
Your response must be concise. 1.08. What is the ratio of the Revenue generated (in %) of Kyrgyz Republic in 2008 to that in 2010?
Ensure brevity in your answer.  0.54. What is the ratio of the Revenue generated (in %) of Lebanon in 2008 to that in 2010?
Give a very brief answer. 0.9. What is the ratio of the Revenue generated (in %) of Low & middle income in 2008 to that in 2011?
Provide a succinct answer. 0.93. What is the ratio of the Revenue generated (in %) of Burkina Faso in 2008 to that in 2011?
Make the answer very short. 0.85. What is the ratio of the Revenue generated (in %) of Kyrgyz Republic in 2008 to that in 2011?
Give a very brief answer. 0.55. What is the ratio of the Revenue generated (in %) of Lebanon in 2008 to that in 2011?
Keep it short and to the point. 0.86. What is the ratio of the Revenue generated (in %) in Low & middle income in 2008 to that in 2012?
Provide a succinct answer. 0.94. What is the ratio of the Revenue generated (in %) in Burkina Faso in 2008 to that in 2012?
Make the answer very short. 0.82. What is the ratio of the Revenue generated (in %) of Kyrgyz Republic in 2008 to that in 2012?
Give a very brief answer. 0.58. What is the ratio of the Revenue generated (in %) of Lebanon in 2008 to that in 2012?
Provide a succinct answer. 0.83. What is the ratio of the Revenue generated (in %) in Burkina Faso in 2009 to that in 2010?
Provide a succinct answer. 0.91. What is the ratio of the Revenue generated (in %) in Kyrgyz Republic in 2009 to that in 2010?
Give a very brief answer. 0.57. What is the ratio of the Revenue generated (in %) of Lebanon in 2009 to that in 2010?
Offer a very short reply. 0.88. What is the ratio of the Revenue generated (in %) of Low & middle income in 2009 to that in 2011?
Offer a terse response. 0.95. What is the ratio of the Revenue generated (in %) in Burkina Faso in 2009 to that in 2011?
Make the answer very short. 0.72. What is the ratio of the Revenue generated (in %) in Kyrgyz Republic in 2009 to that in 2011?
Provide a short and direct response. 0.59. What is the ratio of the Revenue generated (in %) in Lebanon in 2009 to that in 2011?
Provide a short and direct response. 0.84. What is the ratio of the Revenue generated (in %) of Low & middle income in 2009 to that in 2012?
Provide a short and direct response. 0.95. What is the ratio of the Revenue generated (in %) of Burkina Faso in 2009 to that in 2012?
Offer a very short reply. 0.69. What is the ratio of the Revenue generated (in %) of Kyrgyz Republic in 2009 to that in 2012?
Make the answer very short. 0.63. What is the ratio of the Revenue generated (in %) of Lebanon in 2009 to that in 2012?
Give a very brief answer. 0.81. What is the ratio of the Revenue generated (in %) in Low & middle income in 2010 to that in 2011?
Provide a short and direct response. 0.95. What is the ratio of the Revenue generated (in %) in Burkina Faso in 2010 to that in 2011?
Offer a very short reply. 0.79. What is the ratio of the Revenue generated (in %) in Kyrgyz Republic in 2010 to that in 2011?
Offer a very short reply. 1.03. What is the ratio of the Revenue generated (in %) of Lebanon in 2010 to that in 2011?
Ensure brevity in your answer.  0.95. What is the ratio of the Revenue generated (in %) of Low & middle income in 2010 to that in 2012?
Offer a very short reply. 0.95. What is the ratio of the Revenue generated (in %) of Burkina Faso in 2010 to that in 2012?
Give a very brief answer. 0.76. What is the ratio of the Revenue generated (in %) in Kyrgyz Republic in 2010 to that in 2012?
Keep it short and to the point. 1.09. What is the ratio of the Revenue generated (in %) of Lebanon in 2010 to that in 2012?
Your answer should be compact. 0.92. What is the ratio of the Revenue generated (in %) in Low & middle income in 2011 to that in 2012?
Provide a short and direct response. 1.01. What is the ratio of the Revenue generated (in %) of Burkina Faso in 2011 to that in 2012?
Offer a very short reply. 0.96. What is the ratio of the Revenue generated (in %) of Kyrgyz Republic in 2011 to that in 2012?
Make the answer very short. 1.06. What is the ratio of the Revenue generated (in %) in Lebanon in 2011 to that in 2012?
Keep it short and to the point. 0.97. What is the difference between the highest and the second highest Revenue generated (in %) in Low & middle income?
Offer a terse response. 0.19. What is the difference between the highest and the second highest Revenue generated (in %) in Burkina Faso?
Provide a succinct answer. 0.87. What is the difference between the highest and the second highest Revenue generated (in %) of Kyrgyz Republic?
Ensure brevity in your answer.  0.59. What is the difference between the highest and the second highest Revenue generated (in %) of Lebanon?
Your answer should be very brief. 0.61. What is the difference between the highest and the lowest Revenue generated (in %) of Low & middle income?
Make the answer very short. 3.2. What is the difference between the highest and the lowest Revenue generated (in %) in Burkina Faso?
Give a very brief answer. 6.23. What is the difference between the highest and the lowest Revenue generated (in %) in Kyrgyz Republic?
Your response must be concise. 11.54. What is the difference between the highest and the lowest Revenue generated (in %) of Lebanon?
Ensure brevity in your answer.  4.02. 